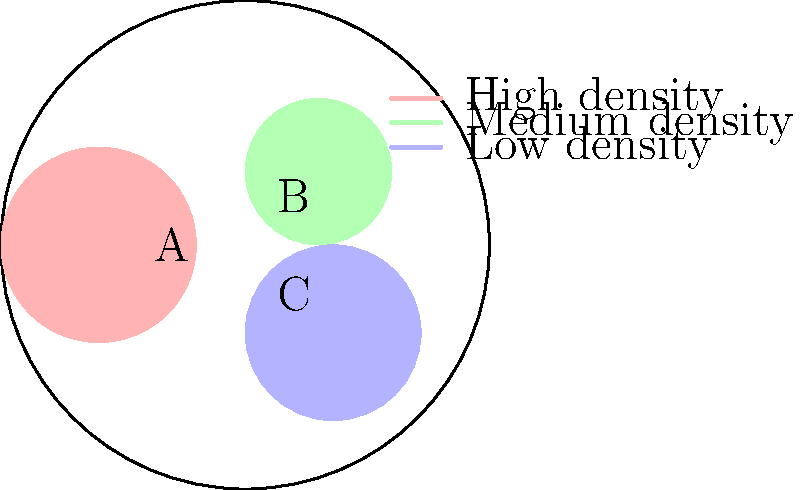Based on the crowd density map of a music festival venue, which area should be prioritized for additional security personnel to manage potential overcrowding? To answer this question, we need to analyze the crowd density patterns shown in the venue map:

1. The venue is divided into three main areas: A, B, and C.
2. Each area is color-coded to represent different crowd densities:
   - Red represents high density
   - Green represents medium density
   - Blue represents low density

3. Analyzing each area:
   - Area A (red): This is the largest colored area and has the highest density.
   - Area B (green): This is a smaller area with medium density.
   - Area C (blue): This is a medium-sized area with low density.

4. When managing crowd safety, areas with the highest density pose the greatest risk for overcrowding and potential safety issues.

5. Therefore, the area that should be prioritized for additional security personnel is the one with the highest density, which is Area A (red).

By focusing additional security efforts on Area A, the concert promoter can better manage the crowd in the most densely populated part of the venue, reducing the risk of safety incidents and ensuring a smoother event experience.
Answer: Area A 